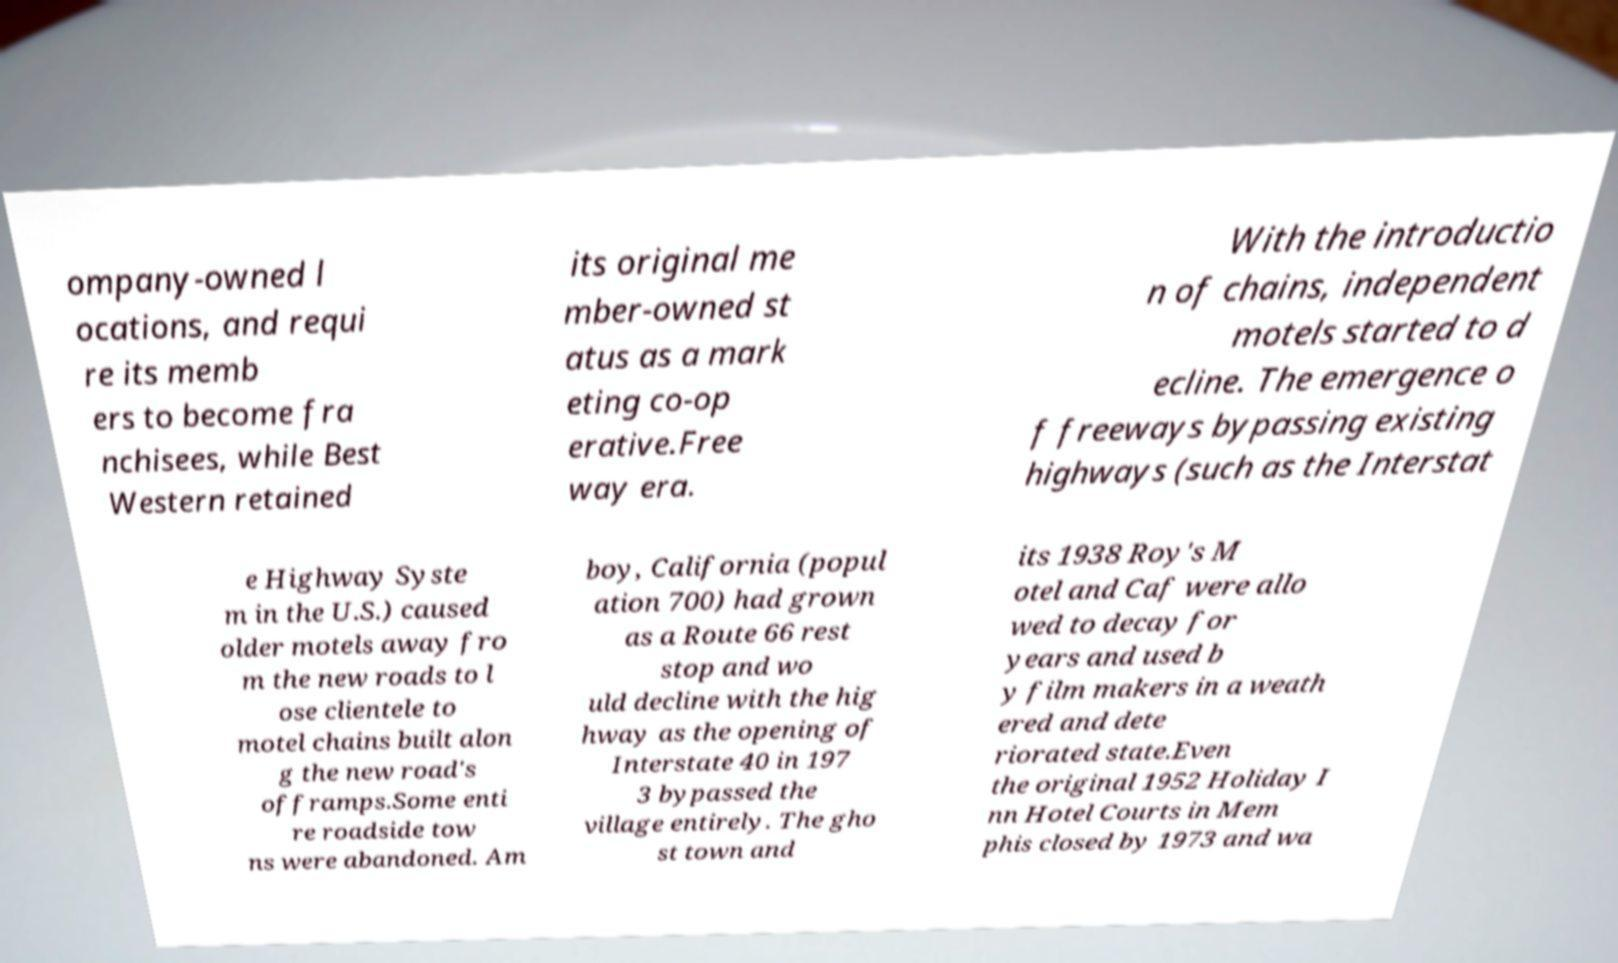For documentation purposes, I need the text within this image transcribed. Could you provide that? ompany-owned l ocations, and requi re its memb ers to become fra nchisees, while Best Western retained its original me mber-owned st atus as a mark eting co-op erative.Free way era. With the introductio n of chains, independent motels started to d ecline. The emergence o f freeways bypassing existing highways (such as the Interstat e Highway Syste m in the U.S.) caused older motels away fro m the new roads to l ose clientele to motel chains built alon g the new road's offramps.Some enti re roadside tow ns were abandoned. Am boy, California (popul ation 700) had grown as a Route 66 rest stop and wo uld decline with the hig hway as the opening of Interstate 40 in 197 3 bypassed the village entirely. The gho st town and its 1938 Roy's M otel and Caf were allo wed to decay for years and used b y film makers in a weath ered and dete riorated state.Even the original 1952 Holiday I nn Hotel Courts in Mem phis closed by 1973 and wa 